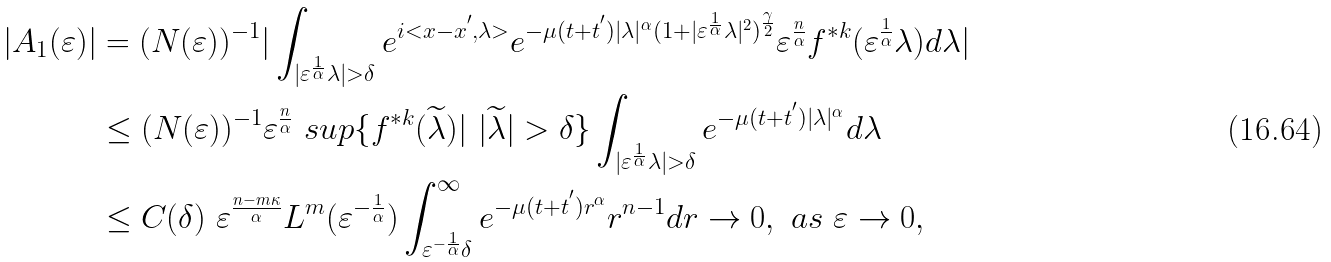Convert formula to latex. <formula><loc_0><loc_0><loc_500><loc_500>| A _ { 1 } ( \varepsilon ) | & = ( N ( \varepsilon ) ) ^ { - 1 } | \int _ { { | \varepsilon ^ { \frac { 1 } { \alpha } } \lambda | > \delta } } e ^ { i < x - x ^ { ^ { \prime } } , \lambda > } e ^ { - \mu ( t + t ^ { ^ { \prime } } ) | \lambda | ^ { \alpha } ( 1 + | \varepsilon ^ { \frac { 1 } { \alpha } } \lambda | ^ { 2 } ) ^ { \frac { \gamma } { 2 } } } \varepsilon ^ { \frac { n } { \alpha } } f ^ { * k } ( \varepsilon ^ { \frac { 1 } { \alpha } } \lambda ) d \lambda | \\ & \leq ( N ( \varepsilon ) ) ^ { - 1 } \varepsilon ^ { \frac { n } { \alpha } } \ s u p \{ f ^ { * k } ( \widetilde { \lambda } ) | \ | \widetilde { \lambda } | > \delta \} \int _ { { | \varepsilon ^ { \frac { 1 } { \alpha } } \lambda | > \delta } } e ^ { - \mu ( t + t ^ { ^ { \prime } } ) | \lambda | ^ { \alpha } } d \lambda \\ & \leq C ( \delta ) \ \varepsilon ^ { \frac { n - m \kappa } { \alpha } } L ^ { m } ( \varepsilon ^ { - \frac { 1 } { \alpha } } ) \int _ { \varepsilon ^ { - \frac { 1 } { \alpha } } \delta } ^ { \infty } e ^ { - \mu ( t + t ^ { ^ { \prime } } ) r ^ { \alpha } } r ^ { n - 1 } d r \rightarrow 0 , \ a s \ \varepsilon \rightarrow 0 ,</formula> 